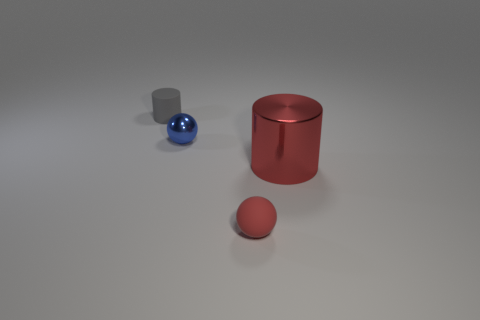Is there anything else that is the same size as the red metallic object?
Your answer should be very brief. No. What number of objects are tiny green matte things or things that are on the left side of the large red object?
Offer a terse response. 3. Is the number of objects that are behind the red metal cylinder greater than the number of red rubber spheres?
Make the answer very short. Yes. Is the number of small red balls on the left side of the tiny shiny ball the same as the number of red objects in front of the tiny gray object?
Your response must be concise. No. There is a small ball behind the tiny red ball; are there any tiny blue metallic objects that are behind it?
Your response must be concise. No. The red shiny object is what shape?
Provide a short and direct response. Cylinder. The rubber thing that is the same color as the large cylinder is what size?
Offer a very short reply. Small. There is a metallic thing on the right side of the red matte thing that is left of the metallic cylinder; how big is it?
Make the answer very short. Large. There is a cylinder that is to the right of the tiny metallic object; what size is it?
Your answer should be compact. Large. Are there fewer rubber objects that are left of the tiny rubber sphere than tiny things that are in front of the small gray thing?
Offer a terse response. Yes. 